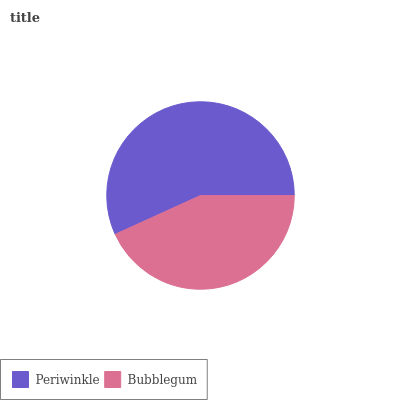Is Bubblegum the minimum?
Answer yes or no. Yes. Is Periwinkle the maximum?
Answer yes or no. Yes. Is Bubblegum the maximum?
Answer yes or no. No. Is Periwinkle greater than Bubblegum?
Answer yes or no. Yes. Is Bubblegum less than Periwinkle?
Answer yes or no. Yes. Is Bubblegum greater than Periwinkle?
Answer yes or no. No. Is Periwinkle less than Bubblegum?
Answer yes or no. No. Is Periwinkle the high median?
Answer yes or no. Yes. Is Bubblegum the low median?
Answer yes or no. Yes. Is Bubblegum the high median?
Answer yes or no. No. Is Periwinkle the low median?
Answer yes or no. No. 